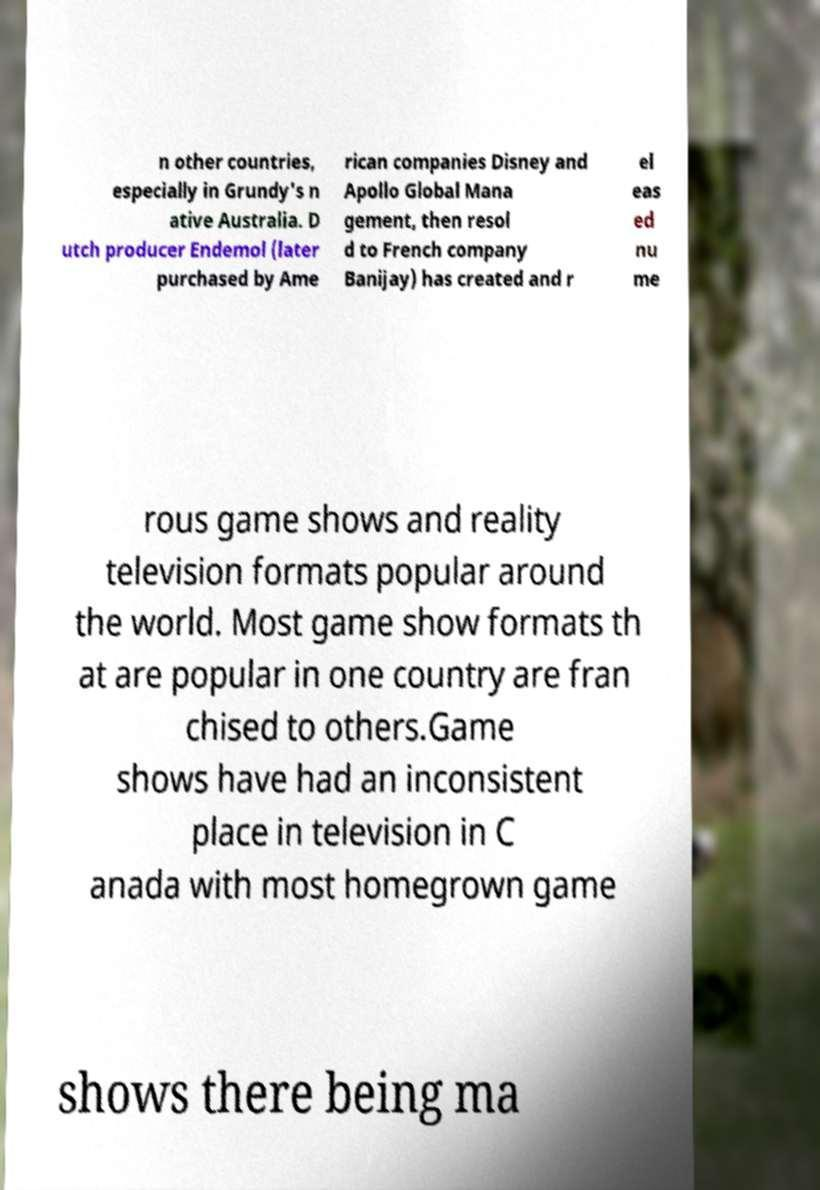Could you assist in decoding the text presented in this image and type it out clearly? n other countries, especially in Grundy's n ative Australia. D utch producer Endemol (later purchased by Ame rican companies Disney and Apollo Global Mana gement, then resol d to French company Banijay) has created and r el eas ed nu me rous game shows and reality television formats popular around the world. Most game show formats th at are popular in one country are fran chised to others.Game shows have had an inconsistent place in television in C anada with most homegrown game shows there being ma 